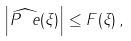<formula> <loc_0><loc_0><loc_500><loc_500>\left | \widehat { P ^ { \ } e } ( \xi ) \right | \leq F ( \xi ) \, ,</formula> 